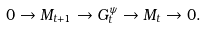<formula> <loc_0><loc_0><loc_500><loc_500>0 \rightarrow M _ { t + 1 } \rightarrow G _ { t } ^ { \psi } \rightarrow M _ { t } \rightarrow 0 .</formula> 